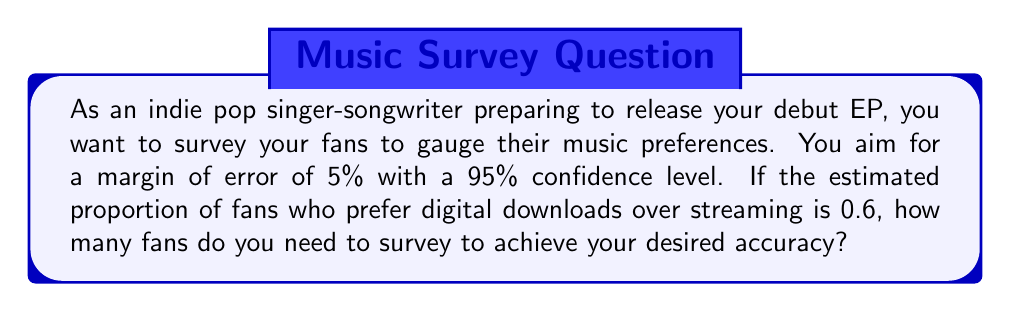Show me your answer to this math problem. To determine the sample size needed for a survey with a specified confidence level and margin of error, we use the following formula:

$$ n = \frac{z^2 \cdot p(1-p)}{E^2} $$

Where:
$n$ = required sample size
$z$ = z-score for the desired confidence level
$p$ = estimated proportion
$E$ = desired margin of error

Step 1: Determine the z-score for a 95% confidence level.
For a 95% confidence level, $z = 1.96$

Step 2: Use the given estimated proportion.
$p = 0.6$

Step 3: Convert the margin of error to a decimal.
$E = 5\% = 0.05$

Step 4: Plug the values into the formula:

$$ n = \frac{1.96^2 \cdot 0.6(1-0.6)}{0.05^2} $$

Step 5: Calculate the result:

$$ n = \frac{3.8416 \cdot 0.24}{0.0025} = 368.7936 $$

Step 6: Round up to the nearest whole number, as we can't survey a fraction of a person.

$n = 369$
Answer: 369 fans 